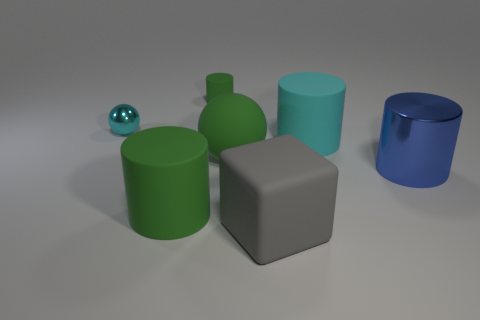What number of large rubber cylinders are the same color as the large ball?
Make the answer very short. 1. Do the cyan metal thing and the green ball have the same size?
Ensure brevity in your answer.  No. There is a thing that is to the left of the big rubber cylinder that is in front of the blue cylinder; what size is it?
Ensure brevity in your answer.  Small. Do the large ball and the tiny thing to the right of the big green cylinder have the same color?
Your answer should be very brief. Yes. Is there a yellow shiny sphere of the same size as the cyan rubber thing?
Make the answer very short. No. How big is the rubber cylinder that is behind the shiny sphere?
Provide a succinct answer. Small. There is a big cylinder in front of the blue cylinder; is there a cyan thing right of it?
Provide a short and direct response. Yes. What number of other objects are the same shape as the big shiny object?
Provide a short and direct response. 3. Does the big gray rubber object have the same shape as the large blue object?
Make the answer very short. No. What is the color of the rubber object that is both to the left of the large ball and in front of the blue metal cylinder?
Offer a very short reply. Green. 